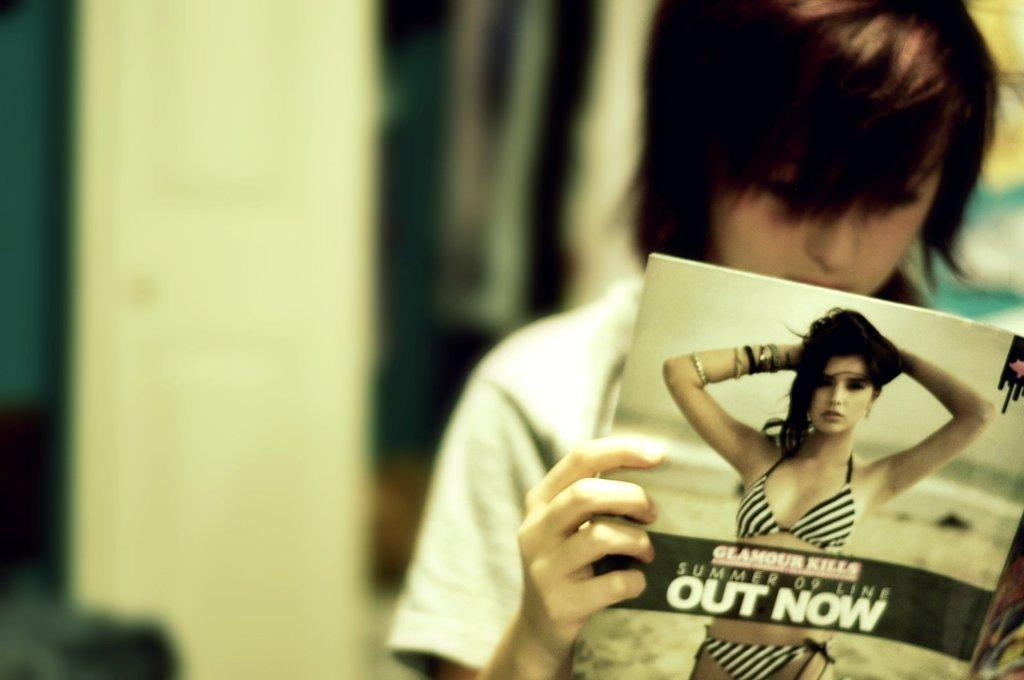What is the person on the right side of the image doing? The person is holding a book. What is the person doing with the book? The person is looking into the book. What can be seen on the book? There is text on the book, and there is an image of a woman on the book. How would you describe the background of the image? The background of the image is blurred. What is the purpose of the bucket in the image? There is no bucket present in the image. How does the person's wealth relate to the image? There is no information about the person's wealth in the image. 